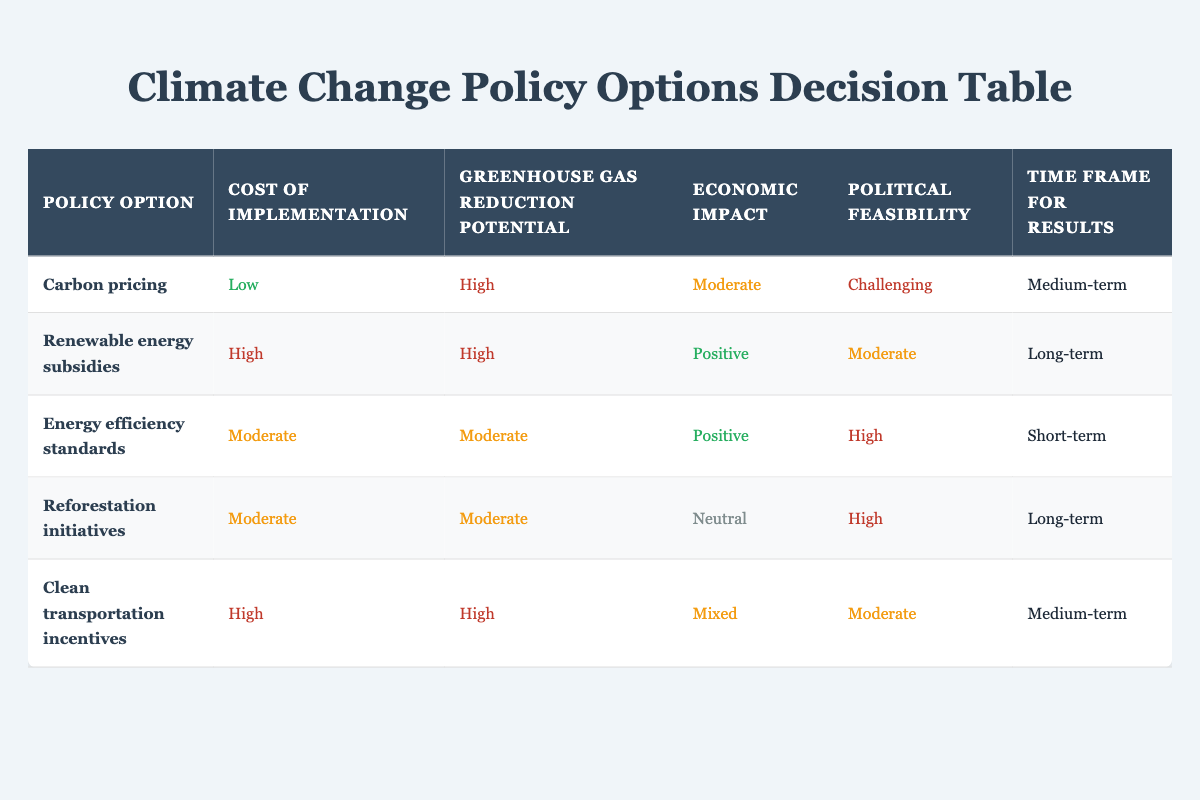What is the greenhouse gas reduction potential of Energy efficiency standards? The table indicates that the greenhouse gas reduction potential for Energy efficiency standards is labeled as "Moderate." This information is directly retrieved from the corresponding row in the table.
Answer: Moderate Which policy option has a low cost of implementation? By reviewing the table, we find that the only policy option categorized as having a "Low" cost of implementation is Carbon pricing. This matches the information in the table specifically for this criterion.
Answer: Carbon pricing Are renewable energy subsidies immediately politically feasible? The table shows that renewable energy subsidies have "Moderate" political feasibility, which indicates that they are not immediately feasible. So the answer is no.
Answer: No What is the time frame for results from Clean transportation incentives? The table states that Clean transportation incentives have a time frame for results of "Medium-term," providing a direct retrieval of information regarding this policy option.
Answer: Medium-term Which options have high greenhouse gas reduction potential? As per the table, there are three options with high greenhouse gas reduction potential: Carbon pricing, Renewable energy subsidies, and Clean transportation incentives. We can identify these by checking the "High" label under the appropriate column for each of these options.
Answer: Carbon pricing, Renewable energy subsidies, Clean transportation incentives What is the average cost of implementation across all options? The cost categories are Low, Moderate, and High. Assigning numeric values: Low = 1, Moderate = 2, High = 3. The total for the costs is (1 + 3 + 2 + 2 + 3) = 11 and dividing by 5 options gives the average cost as 11/5 = 2.2. Rounding gives an average of Moderate.
Answer: Moderate Which option has the highest economic impact? Looking at the economic impact row, Renewable energy subsidies have a "Positive" economic impact, which appears to be the most favorable among the options presented. Other options are classified as "Moderate," "Mixed," or "Neutral," making Renewable energy subsidies stand out.
Answer: Renewable energy subsidies Is there any option that shows a neutral economic impact? The table clearly lists Reforestation initiatives as having a "Neutral" economic impact, confirming the existence of at least one option with this classification.
Answer: Yes Which policy option is both politically feasible and has a short-term results time frame? The only policy option that meets both criteria of being "High" in political feasibility and "Short-term" in the time frame for results is Energy efficiency standards, as verified by cross-referencing both columns in the table.
Answer: Energy efficiency standards How do carbon pricing and clean transportation incentives compare in terms of cost and political feasibility? Carbon pricing has a "Low" cost of implementation and is judged as "Challenging" in political feasibility. In contrast, clean transportation incentives have a "High" cost of implementation and "Moderate" political feasibility. Thus, carbon pricing is less costly but more politically challenging compared to clean transportation incentives, making the former easier to implement economically but harder politically.
Answer: Carbon pricing is low cost, challenging politically; clean transportation incentives are high cost, moderate politically 